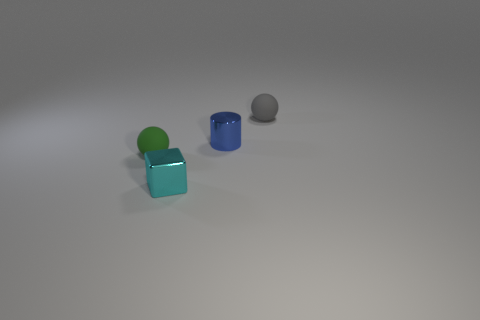What number of other things are the same shape as the small cyan thing?
Offer a terse response. 0. There is a small rubber object that is in front of the tiny gray object; what is its shape?
Keep it short and to the point. Sphere. Is there a blue cylinder that has the same material as the gray thing?
Provide a succinct answer. No. Does the tiny rubber thing that is to the right of the tiny shiny cylinder have the same color as the cylinder?
Your answer should be compact. No. What size is the green object?
Provide a short and direct response. Small. Is there a small thing that is to the left of the tiny matte ball that is to the right of the tiny green rubber object in front of the small gray thing?
Give a very brief answer. Yes. There is a tiny cylinder; what number of small spheres are to the right of it?
Your answer should be compact. 1. How many things have the same color as the small cube?
Keep it short and to the point. 0. How many objects are matte balls on the left side of the tiny gray sphere or small spheres that are on the left side of the blue cylinder?
Give a very brief answer. 1. Is the number of tiny metal blocks greater than the number of purple metallic spheres?
Your answer should be very brief. Yes. 